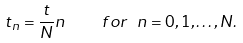<formula> <loc_0><loc_0><loc_500><loc_500>t _ { n } = \frac { t } { N } n \quad f o r \ n = 0 , 1 , \dots , N .</formula> 